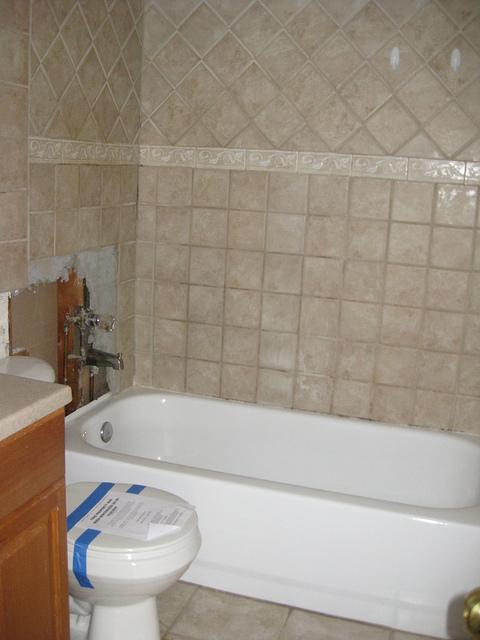What is on the toilet?
Give a very brief answer. Paper. Is there a shower in the room?
Be succinct. No. Is the bathroom new?
Keep it brief. Yes. 